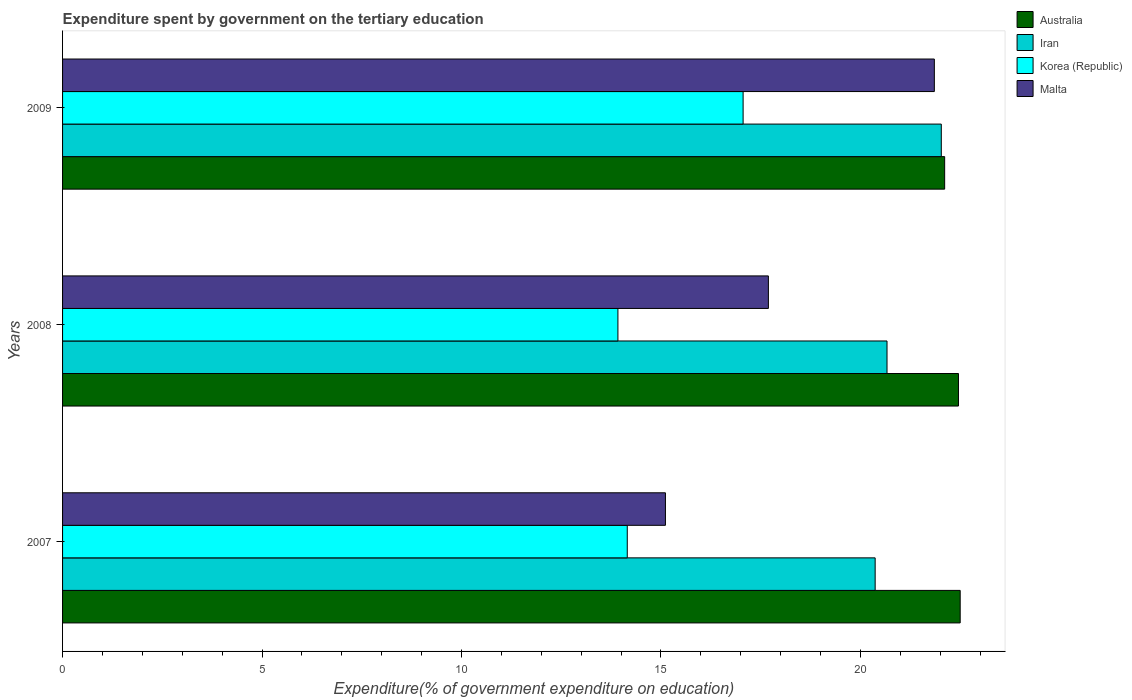What is the label of the 2nd group of bars from the top?
Make the answer very short. 2008. In how many cases, is the number of bars for a given year not equal to the number of legend labels?
Offer a terse response. 0. What is the expenditure spent by government on the tertiary education in Malta in 2009?
Provide a short and direct response. 21.85. Across all years, what is the maximum expenditure spent by government on the tertiary education in Malta?
Your response must be concise. 21.85. Across all years, what is the minimum expenditure spent by government on the tertiary education in Iran?
Offer a terse response. 20.37. In which year was the expenditure spent by government on the tertiary education in Korea (Republic) minimum?
Offer a very short reply. 2008. What is the total expenditure spent by government on the tertiary education in Iran in the graph?
Make the answer very short. 63.07. What is the difference between the expenditure spent by government on the tertiary education in Malta in 2008 and that in 2009?
Provide a short and direct response. -4.16. What is the difference between the expenditure spent by government on the tertiary education in Iran in 2009 and the expenditure spent by government on the tertiary education in Australia in 2007?
Your answer should be compact. -0.47. What is the average expenditure spent by government on the tertiary education in Korea (Republic) per year?
Your response must be concise. 15.05. In the year 2009, what is the difference between the expenditure spent by government on the tertiary education in Malta and expenditure spent by government on the tertiary education in Iran?
Make the answer very short. -0.17. In how many years, is the expenditure spent by government on the tertiary education in Iran greater than 13 %?
Offer a terse response. 3. What is the ratio of the expenditure spent by government on the tertiary education in Australia in 2007 to that in 2008?
Your answer should be compact. 1. What is the difference between the highest and the second highest expenditure spent by government on the tertiary education in Malta?
Your answer should be compact. 4.16. What is the difference between the highest and the lowest expenditure spent by government on the tertiary education in Iran?
Make the answer very short. 1.66. Is the sum of the expenditure spent by government on the tertiary education in Korea (Republic) in 2007 and 2009 greater than the maximum expenditure spent by government on the tertiary education in Iran across all years?
Keep it short and to the point. Yes. Is it the case that in every year, the sum of the expenditure spent by government on the tertiary education in Iran and expenditure spent by government on the tertiary education in Korea (Republic) is greater than the sum of expenditure spent by government on the tertiary education in Malta and expenditure spent by government on the tertiary education in Australia?
Your answer should be very brief. No. What does the 3rd bar from the top in 2007 represents?
Your response must be concise. Iran. What does the 2nd bar from the bottom in 2008 represents?
Your answer should be very brief. Iran. Is it the case that in every year, the sum of the expenditure spent by government on the tertiary education in Iran and expenditure spent by government on the tertiary education in Korea (Republic) is greater than the expenditure spent by government on the tertiary education in Australia?
Keep it short and to the point. Yes. How many bars are there?
Offer a very short reply. 12. What is the difference between two consecutive major ticks on the X-axis?
Offer a terse response. 5. Where does the legend appear in the graph?
Ensure brevity in your answer.  Top right. What is the title of the graph?
Your answer should be compact. Expenditure spent by government on the tertiary education. What is the label or title of the X-axis?
Provide a short and direct response. Expenditure(% of government expenditure on education). What is the Expenditure(% of government expenditure on education) of Australia in 2007?
Make the answer very short. 22.5. What is the Expenditure(% of government expenditure on education) of Iran in 2007?
Provide a short and direct response. 20.37. What is the Expenditure(% of government expenditure on education) in Korea (Republic) in 2007?
Keep it short and to the point. 14.16. What is the Expenditure(% of government expenditure on education) of Malta in 2007?
Make the answer very short. 15.11. What is the Expenditure(% of government expenditure on education) of Australia in 2008?
Offer a terse response. 22.46. What is the Expenditure(% of government expenditure on education) in Iran in 2008?
Your answer should be compact. 20.67. What is the Expenditure(% of government expenditure on education) in Korea (Republic) in 2008?
Offer a terse response. 13.92. What is the Expenditure(% of government expenditure on education) in Malta in 2008?
Provide a succinct answer. 17.69. What is the Expenditure(% of government expenditure on education) in Australia in 2009?
Your answer should be compact. 22.11. What is the Expenditure(% of government expenditure on education) in Iran in 2009?
Make the answer very short. 22.03. What is the Expenditure(% of government expenditure on education) in Korea (Republic) in 2009?
Make the answer very short. 17.06. What is the Expenditure(% of government expenditure on education) in Malta in 2009?
Offer a terse response. 21.85. Across all years, what is the maximum Expenditure(% of government expenditure on education) in Australia?
Your answer should be compact. 22.5. Across all years, what is the maximum Expenditure(% of government expenditure on education) of Iran?
Provide a succinct answer. 22.03. Across all years, what is the maximum Expenditure(% of government expenditure on education) in Korea (Republic)?
Offer a terse response. 17.06. Across all years, what is the maximum Expenditure(% of government expenditure on education) of Malta?
Ensure brevity in your answer.  21.85. Across all years, what is the minimum Expenditure(% of government expenditure on education) of Australia?
Your response must be concise. 22.11. Across all years, what is the minimum Expenditure(% of government expenditure on education) of Iran?
Give a very brief answer. 20.37. Across all years, what is the minimum Expenditure(% of government expenditure on education) of Korea (Republic)?
Your answer should be compact. 13.92. Across all years, what is the minimum Expenditure(% of government expenditure on education) of Malta?
Provide a succinct answer. 15.11. What is the total Expenditure(% of government expenditure on education) in Australia in the graph?
Your answer should be very brief. 67.07. What is the total Expenditure(% of government expenditure on education) of Iran in the graph?
Offer a terse response. 63.07. What is the total Expenditure(% of government expenditure on education) of Korea (Republic) in the graph?
Your answer should be compact. 45.14. What is the total Expenditure(% of government expenditure on education) in Malta in the graph?
Keep it short and to the point. 54.66. What is the difference between the Expenditure(% of government expenditure on education) in Australia in 2007 and that in 2008?
Keep it short and to the point. 0.04. What is the difference between the Expenditure(% of government expenditure on education) in Iran in 2007 and that in 2008?
Provide a succinct answer. -0.3. What is the difference between the Expenditure(% of government expenditure on education) in Korea (Republic) in 2007 and that in 2008?
Give a very brief answer. 0.23. What is the difference between the Expenditure(% of government expenditure on education) of Malta in 2007 and that in 2008?
Offer a very short reply. -2.58. What is the difference between the Expenditure(% of government expenditure on education) in Australia in 2007 and that in 2009?
Offer a very short reply. 0.39. What is the difference between the Expenditure(% of government expenditure on education) in Iran in 2007 and that in 2009?
Provide a succinct answer. -1.66. What is the difference between the Expenditure(% of government expenditure on education) of Korea (Republic) in 2007 and that in 2009?
Your response must be concise. -2.9. What is the difference between the Expenditure(% of government expenditure on education) in Malta in 2007 and that in 2009?
Your answer should be compact. -6.74. What is the difference between the Expenditure(% of government expenditure on education) of Australia in 2008 and that in 2009?
Your answer should be very brief. 0.35. What is the difference between the Expenditure(% of government expenditure on education) of Iran in 2008 and that in 2009?
Offer a very short reply. -1.36. What is the difference between the Expenditure(% of government expenditure on education) in Korea (Republic) in 2008 and that in 2009?
Your response must be concise. -3.14. What is the difference between the Expenditure(% of government expenditure on education) in Malta in 2008 and that in 2009?
Ensure brevity in your answer.  -4.16. What is the difference between the Expenditure(% of government expenditure on education) in Australia in 2007 and the Expenditure(% of government expenditure on education) in Iran in 2008?
Make the answer very short. 1.83. What is the difference between the Expenditure(% of government expenditure on education) of Australia in 2007 and the Expenditure(% of government expenditure on education) of Korea (Republic) in 2008?
Keep it short and to the point. 8.58. What is the difference between the Expenditure(% of government expenditure on education) in Australia in 2007 and the Expenditure(% of government expenditure on education) in Malta in 2008?
Ensure brevity in your answer.  4.81. What is the difference between the Expenditure(% of government expenditure on education) in Iran in 2007 and the Expenditure(% of government expenditure on education) in Korea (Republic) in 2008?
Ensure brevity in your answer.  6.45. What is the difference between the Expenditure(% of government expenditure on education) in Iran in 2007 and the Expenditure(% of government expenditure on education) in Malta in 2008?
Keep it short and to the point. 2.68. What is the difference between the Expenditure(% of government expenditure on education) of Korea (Republic) in 2007 and the Expenditure(% of government expenditure on education) of Malta in 2008?
Keep it short and to the point. -3.54. What is the difference between the Expenditure(% of government expenditure on education) in Australia in 2007 and the Expenditure(% of government expenditure on education) in Iran in 2009?
Your response must be concise. 0.47. What is the difference between the Expenditure(% of government expenditure on education) in Australia in 2007 and the Expenditure(% of government expenditure on education) in Korea (Republic) in 2009?
Make the answer very short. 5.44. What is the difference between the Expenditure(% of government expenditure on education) of Australia in 2007 and the Expenditure(% of government expenditure on education) of Malta in 2009?
Offer a terse response. 0.65. What is the difference between the Expenditure(% of government expenditure on education) of Iran in 2007 and the Expenditure(% of government expenditure on education) of Korea (Republic) in 2009?
Your answer should be compact. 3.31. What is the difference between the Expenditure(% of government expenditure on education) of Iran in 2007 and the Expenditure(% of government expenditure on education) of Malta in 2009?
Ensure brevity in your answer.  -1.48. What is the difference between the Expenditure(% of government expenditure on education) of Korea (Republic) in 2007 and the Expenditure(% of government expenditure on education) of Malta in 2009?
Your response must be concise. -7.7. What is the difference between the Expenditure(% of government expenditure on education) in Australia in 2008 and the Expenditure(% of government expenditure on education) in Iran in 2009?
Give a very brief answer. 0.43. What is the difference between the Expenditure(% of government expenditure on education) of Australia in 2008 and the Expenditure(% of government expenditure on education) of Korea (Republic) in 2009?
Provide a succinct answer. 5.4. What is the difference between the Expenditure(% of government expenditure on education) in Australia in 2008 and the Expenditure(% of government expenditure on education) in Malta in 2009?
Provide a succinct answer. 0.6. What is the difference between the Expenditure(% of government expenditure on education) of Iran in 2008 and the Expenditure(% of government expenditure on education) of Korea (Republic) in 2009?
Provide a short and direct response. 3.61. What is the difference between the Expenditure(% of government expenditure on education) in Iran in 2008 and the Expenditure(% of government expenditure on education) in Malta in 2009?
Keep it short and to the point. -1.19. What is the difference between the Expenditure(% of government expenditure on education) of Korea (Republic) in 2008 and the Expenditure(% of government expenditure on education) of Malta in 2009?
Your response must be concise. -7.93. What is the average Expenditure(% of government expenditure on education) in Australia per year?
Your response must be concise. 22.36. What is the average Expenditure(% of government expenditure on education) of Iran per year?
Ensure brevity in your answer.  21.02. What is the average Expenditure(% of government expenditure on education) in Korea (Republic) per year?
Your answer should be compact. 15.05. What is the average Expenditure(% of government expenditure on education) in Malta per year?
Give a very brief answer. 18.22. In the year 2007, what is the difference between the Expenditure(% of government expenditure on education) in Australia and Expenditure(% of government expenditure on education) in Iran?
Your answer should be compact. 2.13. In the year 2007, what is the difference between the Expenditure(% of government expenditure on education) in Australia and Expenditure(% of government expenditure on education) in Korea (Republic)?
Ensure brevity in your answer.  8.35. In the year 2007, what is the difference between the Expenditure(% of government expenditure on education) in Australia and Expenditure(% of government expenditure on education) in Malta?
Your answer should be very brief. 7.39. In the year 2007, what is the difference between the Expenditure(% of government expenditure on education) in Iran and Expenditure(% of government expenditure on education) in Korea (Republic)?
Offer a very short reply. 6.21. In the year 2007, what is the difference between the Expenditure(% of government expenditure on education) of Iran and Expenditure(% of government expenditure on education) of Malta?
Offer a very short reply. 5.26. In the year 2007, what is the difference between the Expenditure(% of government expenditure on education) of Korea (Republic) and Expenditure(% of government expenditure on education) of Malta?
Your response must be concise. -0.96. In the year 2008, what is the difference between the Expenditure(% of government expenditure on education) in Australia and Expenditure(% of government expenditure on education) in Iran?
Your response must be concise. 1.79. In the year 2008, what is the difference between the Expenditure(% of government expenditure on education) of Australia and Expenditure(% of government expenditure on education) of Korea (Republic)?
Ensure brevity in your answer.  8.54. In the year 2008, what is the difference between the Expenditure(% of government expenditure on education) of Australia and Expenditure(% of government expenditure on education) of Malta?
Your answer should be very brief. 4.76. In the year 2008, what is the difference between the Expenditure(% of government expenditure on education) of Iran and Expenditure(% of government expenditure on education) of Korea (Republic)?
Offer a very short reply. 6.75. In the year 2008, what is the difference between the Expenditure(% of government expenditure on education) in Iran and Expenditure(% of government expenditure on education) in Malta?
Your answer should be very brief. 2.97. In the year 2008, what is the difference between the Expenditure(% of government expenditure on education) of Korea (Republic) and Expenditure(% of government expenditure on education) of Malta?
Offer a terse response. -3.77. In the year 2009, what is the difference between the Expenditure(% of government expenditure on education) in Australia and Expenditure(% of government expenditure on education) in Iran?
Give a very brief answer. 0.08. In the year 2009, what is the difference between the Expenditure(% of government expenditure on education) of Australia and Expenditure(% of government expenditure on education) of Korea (Republic)?
Offer a terse response. 5.05. In the year 2009, what is the difference between the Expenditure(% of government expenditure on education) in Australia and Expenditure(% of government expenditure on education) in Malta?
Give a very brief answer. 0.26. In the year 2009, what is the difference between the Expenditure(% of government expenditure on education) in Iran and Expenditure(% of government expenditure on education) in Korea (Republic)?
Offer a terse response. 4.97. In the year 2009, what is the difference between the Expenditure(% of government expenditure on education) in Iran and Expenditure(% of government expenditure on education) in Malta?
Provide a short and direct response. 0.17. In the year 2009, what is the difference between the Expenditure(% of government expenditure on education) in Korea (Republic) and Expenditure(% of government expenditure on education) in Malta?
Give a very brief answer. -4.79. What is the ratio of the Expenditure(% of government expenditure on education) of Australia in 2007 to that in 2008?
Provide a short and direct response. 1. What is the ratio of the Expenditure(% of government expenditure on education) in Iran in 2007 to that in 2008?
Ensure brevity in your answer.  0.99. What is the ratio of the Expenditure(% of government expenditure on education) in Korea (Republic) in 2007 to that in 2008?
Your answer should be compact. 1.02. What is the ratio of the Expenditure(% of government expenditure on education) of Malta in 2007 to that in 2008?
Keep it short and to the point. 0.85. What is the ratio of the Expenditure(% of government expenditure on education) in Australia in 2007 to that in 2009?
Offer a very short reply. 1.02. What is the ratio of the Expenditure(% of government expenditure on education) of Iran in 2007 to that in 2009?
Provide a short and direct response. 0.92. What is the ratio of the Expenditure(% of government expenditure on education) of Korea (Republic) in 2007 to that in 2009?
Offer a very short reply. 0.83. What is the ratio of the Expenditure(% of government expenditure on education) in Malta in 2007 to that in 2009?
Your answer should be compact. 0.69. What is the ratio of the Expenditure(% of government expenditure on education) in Australia in 2008 to that in 2009?
Your answer should be compact. 1.02. What is the ratio of the Expenditure(% of government expenditure on education) in Iran in 2008 to that in 2009?
Provide a short and direct response. 0.94. What is the ratio of the Expenditure(% of government expenditure on education) of Korea (Republic) in 2008 to that in 2009?
Offer a very short reply. 0.82. What is the ratio of the Expenditure(% of government expenditure on education) of Malta in 2008 to that in 2009?
Your answer should be very brief. 0.81. What is the difference between the highest and the second highest Expenditure(% of government expenditure on education) of Australia?
Provide a succinct answer. 0.04. What is the difference between the highest and the second highest Expenditure(% of government expenditure on education) of Iran?
Give a very brief answer. 1.36. What is the difference between the highest and the second highest Expenditure(% of government expenditure on education) in Korea (Republic)?
Your response must be concise. 2.9. What is the difference between the highest and the second highest Expenditure(% of government expenditure on education) in Malta?
Provide a short and direct response. 4.16. What is the difference between the highest and the lowest Expenditure(% of government expenditure on education) of Australia?
Offer a very short reply. 0.39. What is the difference between the highest and the lowest Expenditure(% of government expenditure on education) in Iran?
Give a very brief answer. 1.66. What is the difference between the highest and the lowest Expenditure(% of government expenditure on education) in Korea (Republic)?
Your answer should be compact. 3.14. What is the difference between the highest and the lowest Expenditure(% of government expenditure on education) in Malta?
Give a very brief answer. 6.74. 